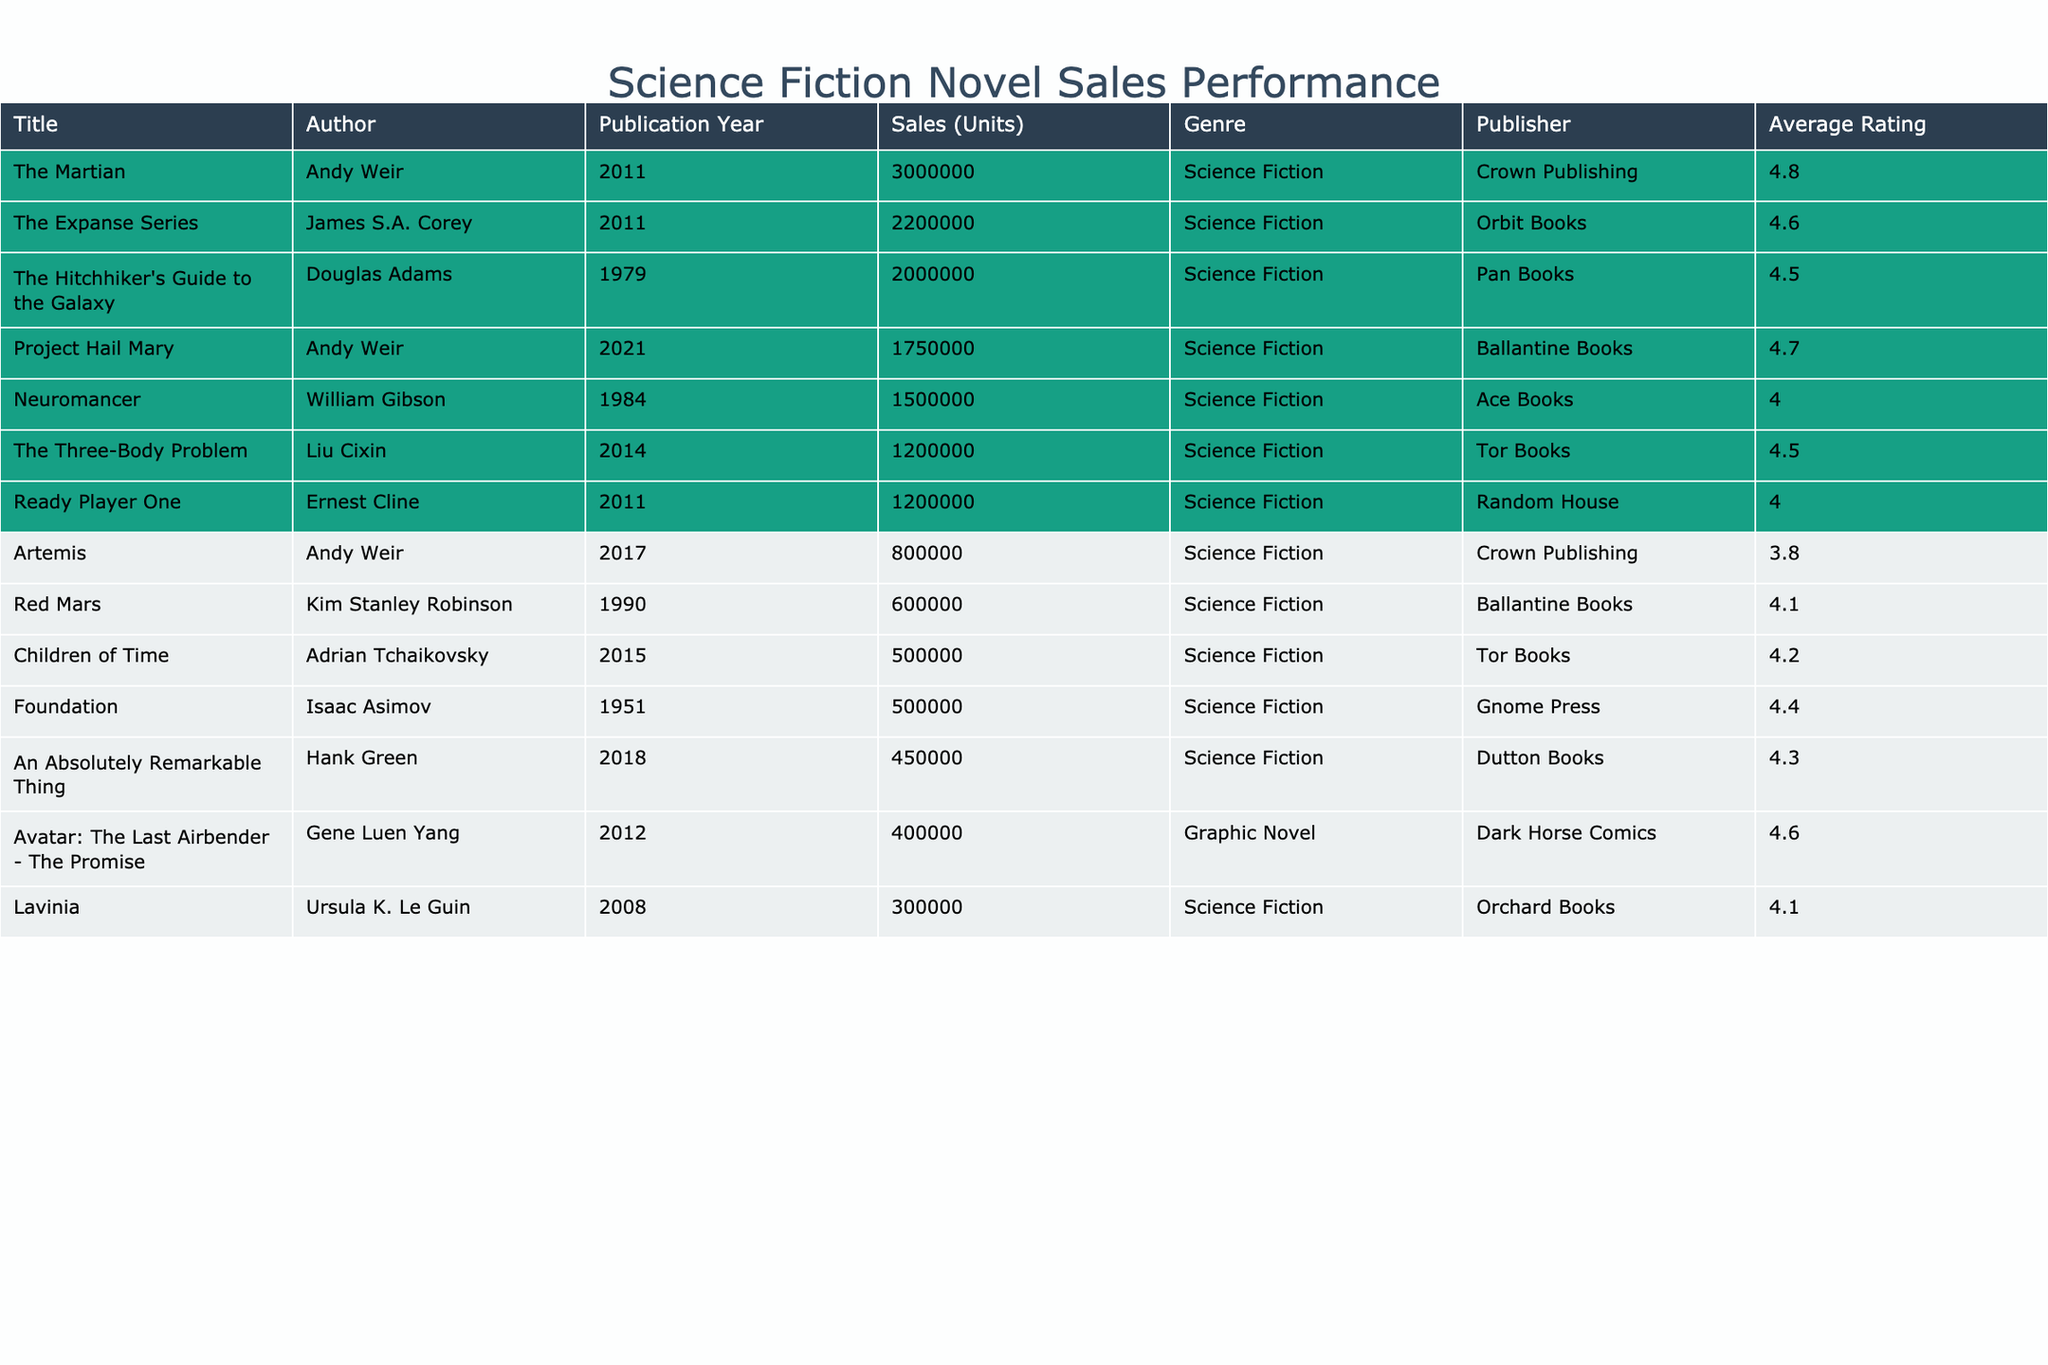What is the highest-selling science fiction novel in the past decade? Referring to the table, "The Martian" by Andy Weir has the highest sales with 3,000,000 units sold.
Answer: 3,000,000 How many science fiction novels have sales exceeding 1 million units? In the table, there are five science fiction novels: "The Martian," "Project Hail Mary," "The Expanse Series," "The Three-Body Problem," and "Ready Player One" that exceed 1 million units in sales.
Answer: 5 What is the average rating of the science fiction novels listed in the table? The total ratings are 4.5 + 3.8 + 4.2 + 4.1 + 4.6 + 4.8 + 4.0 + 4.3 + 4.7 + 4.0 + 4.5 + 4.4 + 4.1 = 52.5. There are 13 novels, so the average rating is 52.5/13 = 4.04.
Answer: 4.04 Did "Children of Time" outsell "Artemis"? "Children of Time" had sales of 500,000 units while "Artemis" had 800,000 units sold, so "Children of Time" did not outsell "Artemis."
Answer: No What is the difference in sales between "The Expanse Series" and "The Hitchhiker's Guide to the Galaxy"? "The Expanse Series" sold 2,200,000 units while "The Hitchhiker's Guide to the Galaxy" sold 2,000,000 units. The difference is 2,200,000 - 2,000,000 = 200,000 units.
Answer: 200,000 Which author has the most high-rated novels (4.5 or above) in the table? The authors are Andy Weir (3), Liu Cixin (1), Adrian Tchaikovsky (1), James S.A. Corey (1), and Douglas Adams (1). The author with the most high-rated novels is Andy Weir with three novels.
Answer: Andy Weir What percentage of the total units sold were from "The Martian"? The total sales are 11,600,000 units. "The Martian" has sales of 3,000,000 units. The percentage is (3,000,000 / 11,600,000) * 100 ≈ 25.86%.
Answer: 25.86% Which genre had the highest average rating among listings? The table indicates all listed books are science fiction, with an average rating of 4.04 based on provided ratings.
Answer: Science Fiction 